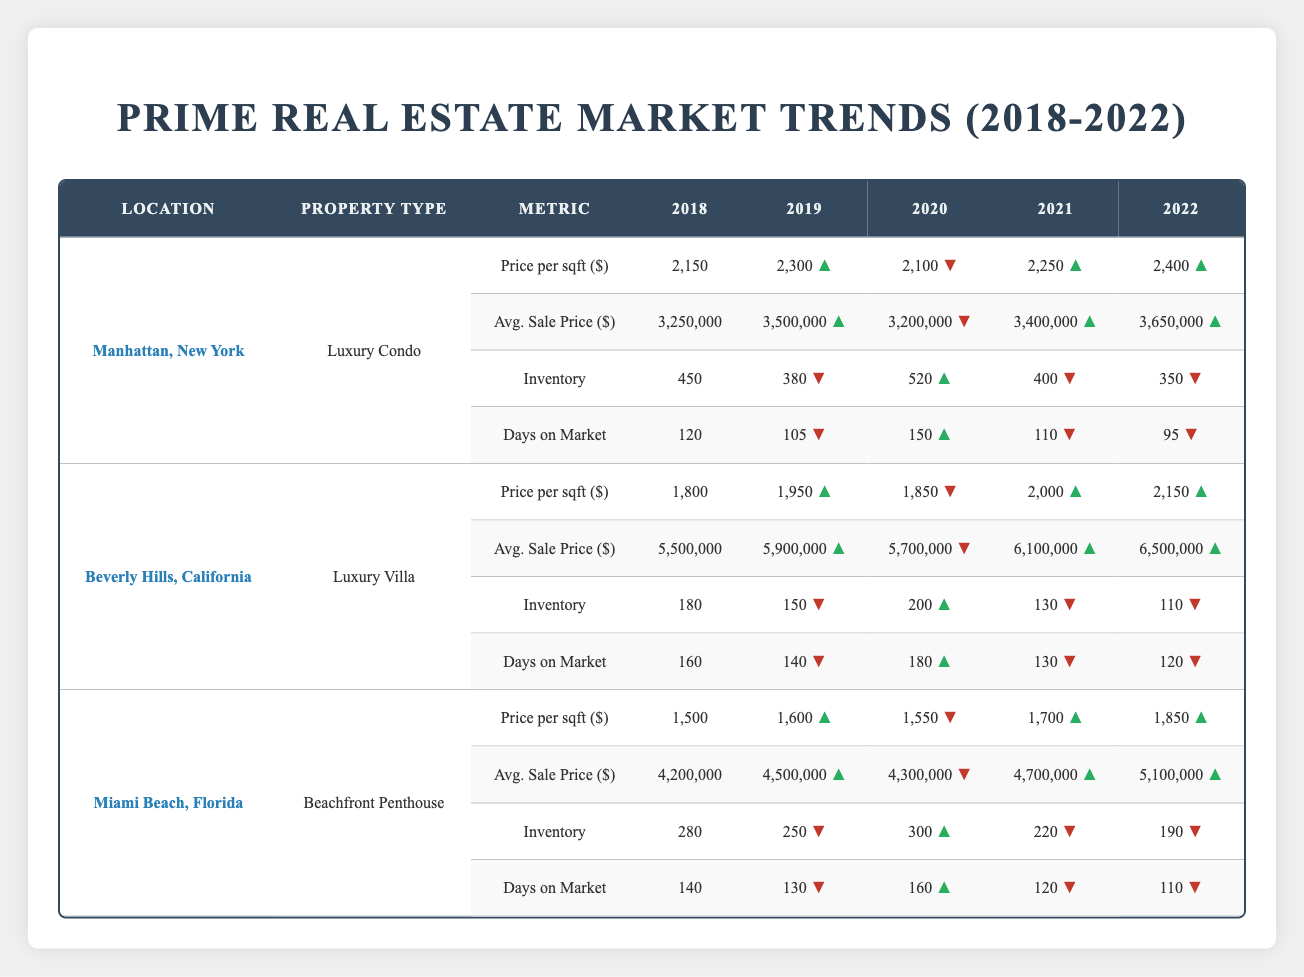What is the average sale price for Luxury Villas in Beverly Hills in 2021? The average sale price for Luxury Villas in Beverly Hills in 2021 is listed in the table as 6,100,000.
Answer: 6,100,000 In which year did the price per square foot of Beachfront Penthouses in Miami Beach show the greatest increase? By comparing the years in the table, the price per square foot of Beachfront Penthouses increased from 1,600 in 2019 to 1,700 in 2021 showing a rise of 100, while in 2022 it increased to 1,850, which is a rise of 150 from 2021. However, the largest increase was from 1,500 in 2018 to 1,600 in 2019, thus the greatest increase was 100 from 2019 to 2020.
Answer: 100 Did inventory of Luxury Condos in Manhattan decrease from 2018 to 2022? Looking at the table, the inventory for Luxury Condos in Manhattan was 450 in 2018 and decreased to 350 by 2022. Therefore, there was a decrease in inventory over this period.
Answer: Yes What was the change in average sale price for Luxury Villas in Beverly Hills from 2018 to 2022? The average sale price for Luxury Villas in Beverly Hills was 5,500,000 in 2018 and increased to 6,500,000 in 2022. The change is calculated as 6,500,000 - 5,500,000 = 1,000,000, indicating an increase of 1,000,000 over the span of four years.
Answer: 1,000,000 Which property type in Manhattan had the lowest inventory in 2022? When looking at the table for Manhattan in 2022, the Luxury Condo had an inventory of 350 which is less compared to the other two properties listed for comparison in Beverly Hills and Miami Beach for that year. Hence, the Luxury Condo had the lowest inventory.
Answer: Luxury Condo 